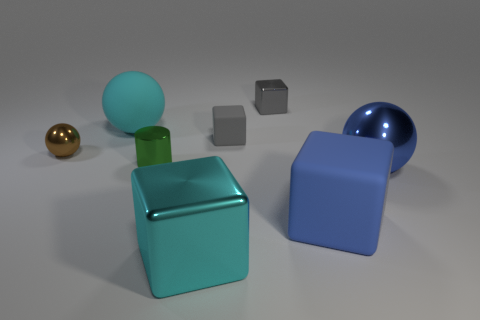What could the scene represent if it were part of a story? The scene might represent a setting where different characters, symbolized by the variously colored and shaped objects, interact in an abstract environment, leading to a narrative about diversity or individuality. 